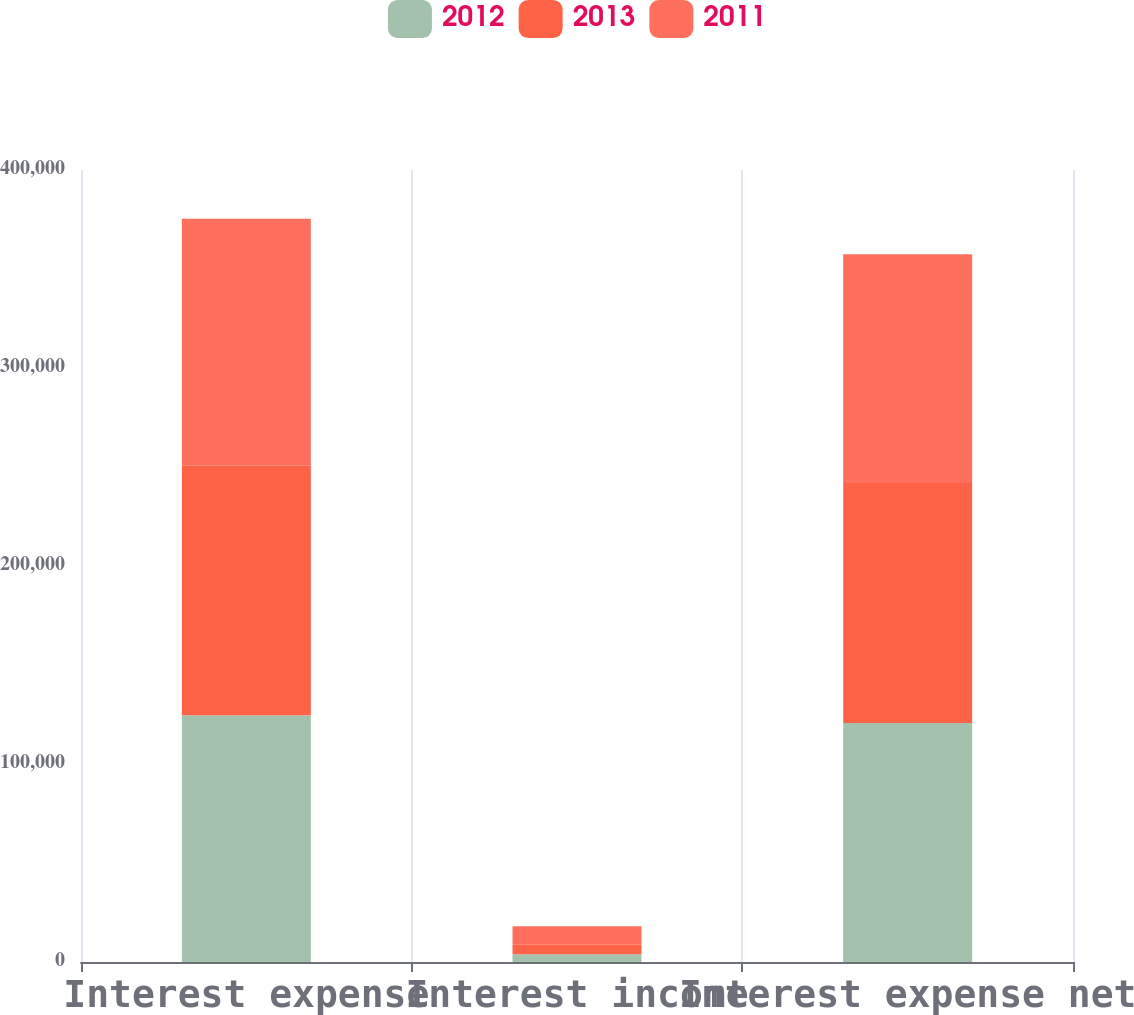Convert chart. <chart><loc_0><loc_0><loc_500><loc_500><stacked_bar_chart><ecel><fcel>Interest expense<fcel>Interest income<fcel>Interest expense net<nl><fcel>2012<fcel>124647<fcel>3905<fcel>120742<nl><fcel>2013<fcel>125995<fcel>4854<fcel>121141<nl><fcel>2011<fcel>124783<fcel>9258<fcel>115525<nl></chart> 